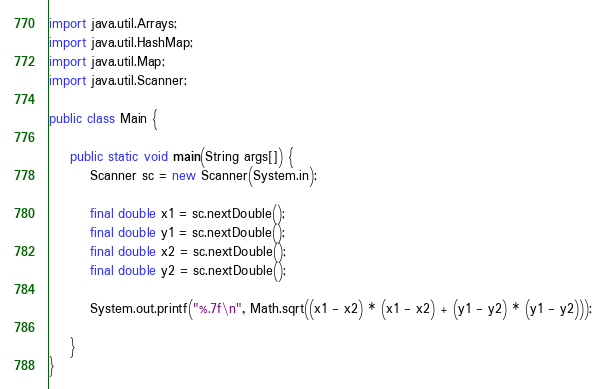Convert code to text. <code><loc_0><loc_0><loc_500><loc_500><_Java_>import java.util.Arrays;
import java.util.HashMap;
import java.util.Map;
import java.util.Scanner;

public class Main {

	public static void main(String args[]) {
		Scanner sc = new Scanner(System.in);
		
		final double x1 = sc.nextDouble();
		final double y1 = sc.nextDouble();
		final double x2 = sc.nextDouble();
		final double y2 = sc.nextDouble();
		
		System.out.printf("%.7f\n", Math.sqrt((x1 - x2) * (x1 - x2) + (y1 - y2) * (y1 - y2)));
		
	}
}</code> 